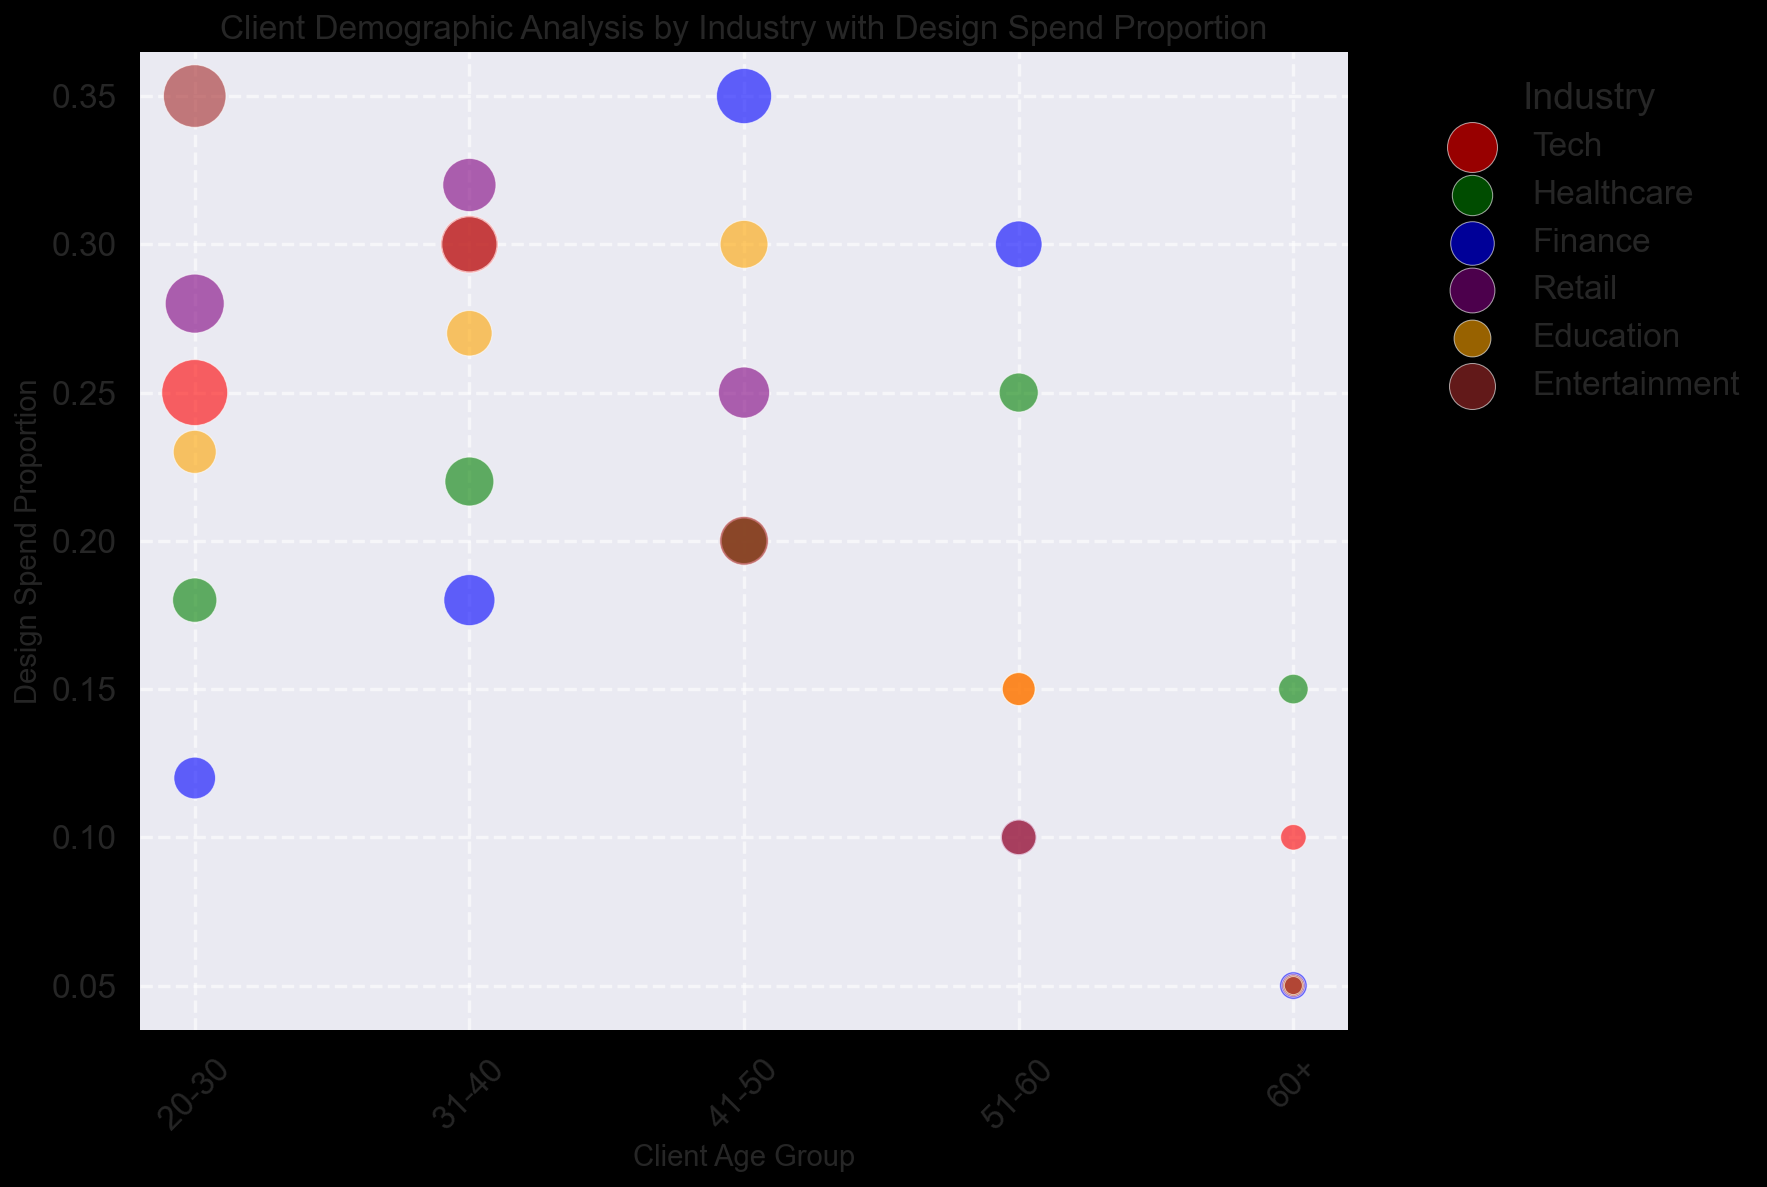What age group in the Tech industry has the highest design spend proportion? Look for the largest bubble in the Tech industry that has the highest position on the y-axis, which represents design spend proportion. In the Tech industry, the 31-40 age group has the highest design spend proportion of 0.30.
Answer: 31-40 Which industry has the largest bubble for the 41-50 age group? Locate the age group 41-50 on the x-axis and identify the largest bubble across all industries. The largest bubble for this age group, in terms of diameter, belongs to the Finance industry.
Answer: Finance What is the total number of clients in the Healthcare industry? Sum the number of clients for all age groups in the Healthcare industry. The counts are: 90 (20-30) + 110 (31-40) + 95 (41-50) + 70 (51-60) + 40 (60+). This totals 405 clients.
Answer: 405 Which industry has clients with the lowest design spend proportion for the 60+ age group? Look at the y-axis values for the 60+ age group across all industries. The lowest design spend proportion of 0.05 is found in the Finance, Retail, Education, and Entertainment industries.
Answer: Finance, Retail, Education, Entertainment Which age group has the highest design spend proportion in the Education industry? Identify the largest bubble in terms of its vertical position on the y-axis within the Education industry. The largest vertical position corresponds to the 41-50 age group, with a spend proportion of 0.30.
Answer: 41-50 Compare the design spend proportion of 20-30 age group between Tech and Retail industries. Which is greater? Check the y-axis values for the 20-30 age group bubbles in both the Tech and Retail industries. The Tech industry has a design spend proportion of 0.25 and the Retail industry has 0.28. Retail has a greater proportion.
Answer: Retail If a newcomer to the freelance graphic design market wants to target clients with the highest design spend, which industry and age group should they focus on? Identify the largest bubble, which indicates both a high number of clients and high design spend proportion. This is found in the 20-30 age group of the Entertainment industry with a proportion of 0.35.
Answer: Entertainment, 20-30 What proportion of design spend do the 51-60 age groups in the Healthcare and Finance industries have, and how do they compare? The spend proportions for the 51-60 age group are 0.25 in Healthcare and 0.30 in Finance. Compare these values to see that the Finance industry has a higher design spend proportion for this age group.
Answer: Healthcare: 0.25, Finance: 0.30 Which industry shows the highest design spend proportion for the 31-40 age group? Examine the bubbles within the 31-40 age group on the x-axis. The Retail industry has the highest y-axis value (proportion) of 0.32 for this age group.
Answer: Retail 